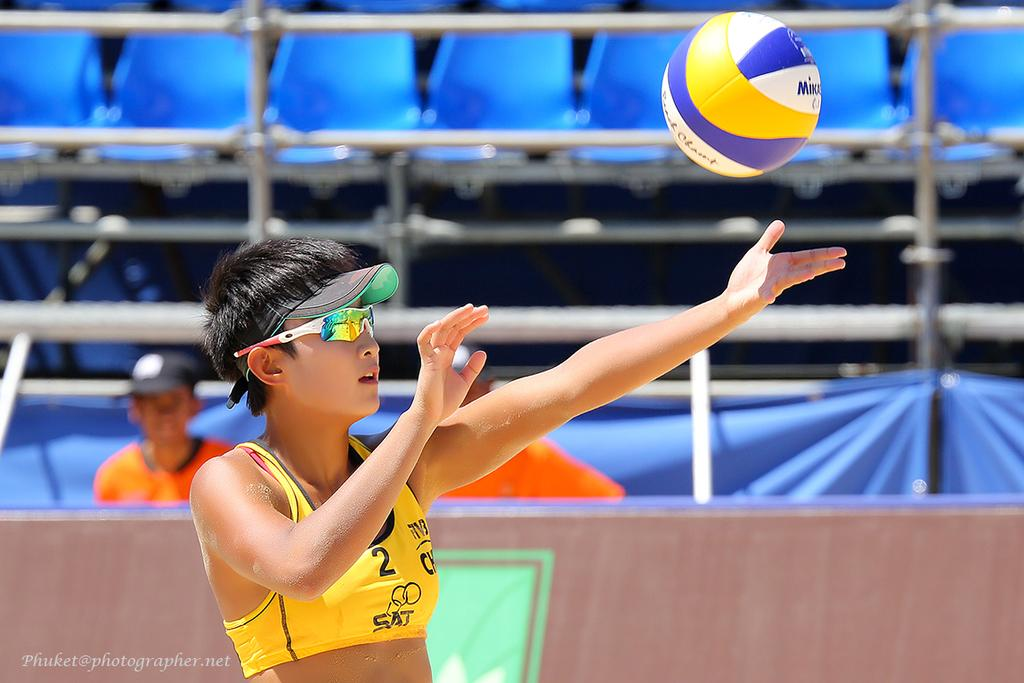Provide a one-sentence caption for the provided image. A woman in a yellow sports bra with the number 2 on it is playing volleyball. 